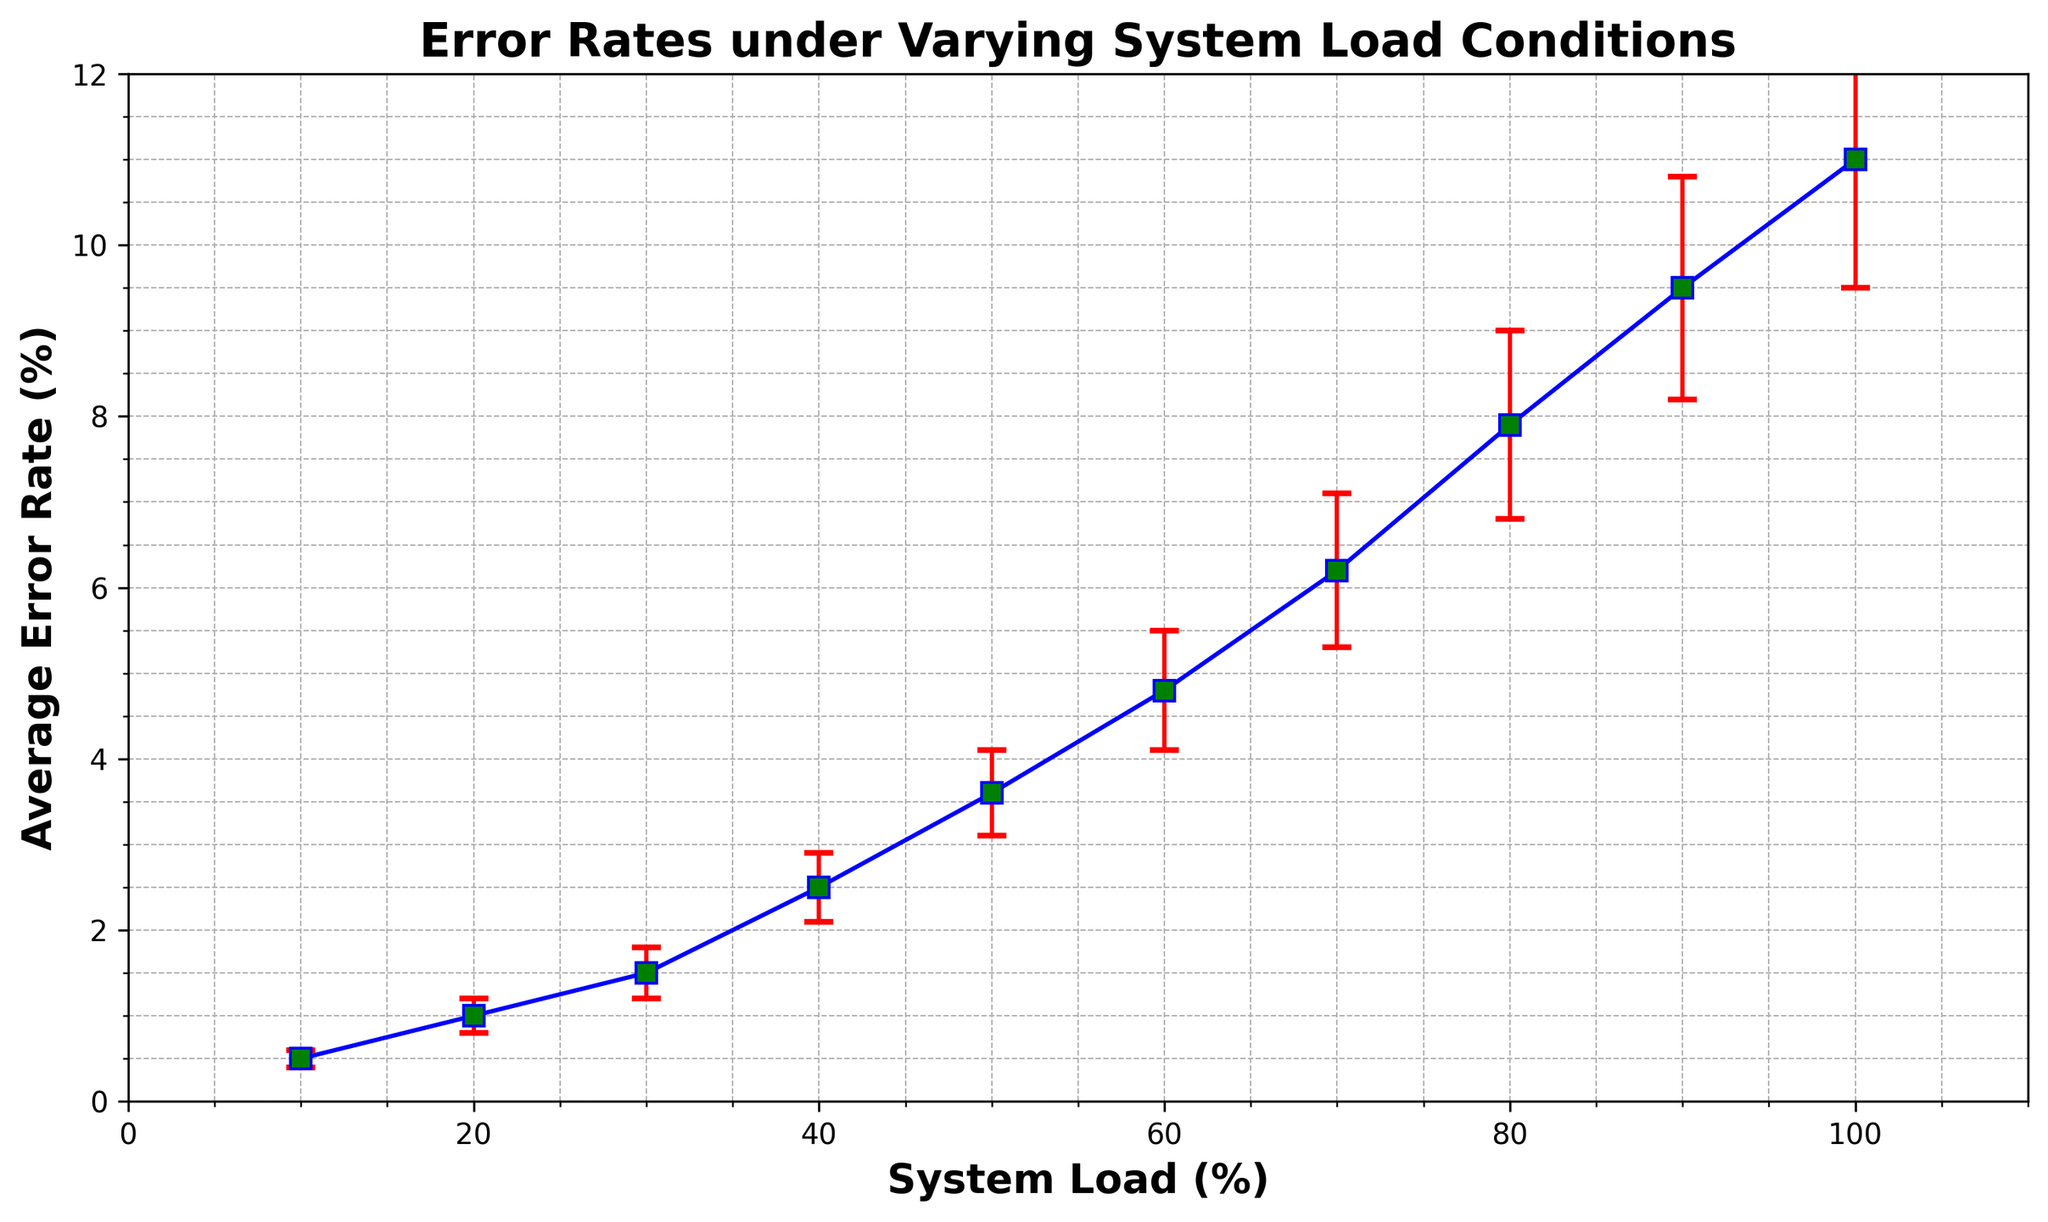What is the error rate at 50% system load? Find the data point where System Load is 50% and read the corresponding Average Error Rate. The error rate at 50% system load is 3.6%.
Answer: 3.6% How much does the error rate increase when the system load goes from 20% to 40%? Subtract the Average Error Rate at 20% system load from the Average Error Rate at 40% system load: 2.5% - 1.0% = 1.5%. The error rate increases by 1.5%.
Answer: 1.5% What is the trend of the error rate as the system load increases? Observe the graph where the error rate curve continuously rises with increasing system load. This indicates a positive correlation where the error rate increases as system load increases.
Answer: Increases What is the difference in the error rate between the highest and lowest system loads? Subtract the Average Error Rate at lowest system load (10%) from the Average Error Rate at highest system load (100%): 11.0% - 0.5% = 10.5%. The difference in error rate is 10.5%.
Answer: 10.5% At what system load do the error bars become the largest? Observe the length of the error bars on the plot. The largest error bar appears at the highest system load, which is 100%.
Answer: 100% Which system load has a moderate error rate of approximately 4%? Identify the data point where the Average Error Rate is closest to 4%. The system load with an error rate around 4% is 60%.
Answer: 60% How does the error rate change between 70% and 80% system load? Subtract the Average Error Rate at 70% system load from the Average Error Rate at 80% system load: 7.9% - 6.2% = 1.7%. Thus, the error rate increases by 1.7%.
Answer: 1.7% What is the average error rate across all system loads? Sum up all the Average Error Rates and divide by the number of data points: (0.5% + 1.0% + 1.5% + 2.5% + 3.6% + 4.8% + 6.2% + 7.9% + 9.5% + 11.0%) / 10 = 48.5% / 10 = 4.85%. The average error rate is 4.85%.
Answer: 4.85% Compare the error rate variability between 30% and 60% system load. Which has the greater error bar? Compare the error bars at 30% and 60% system load, 0.3% and 0.7%, respectively. The 60% system load has a greater error bar value of 0.7%.
Answer: 60% 